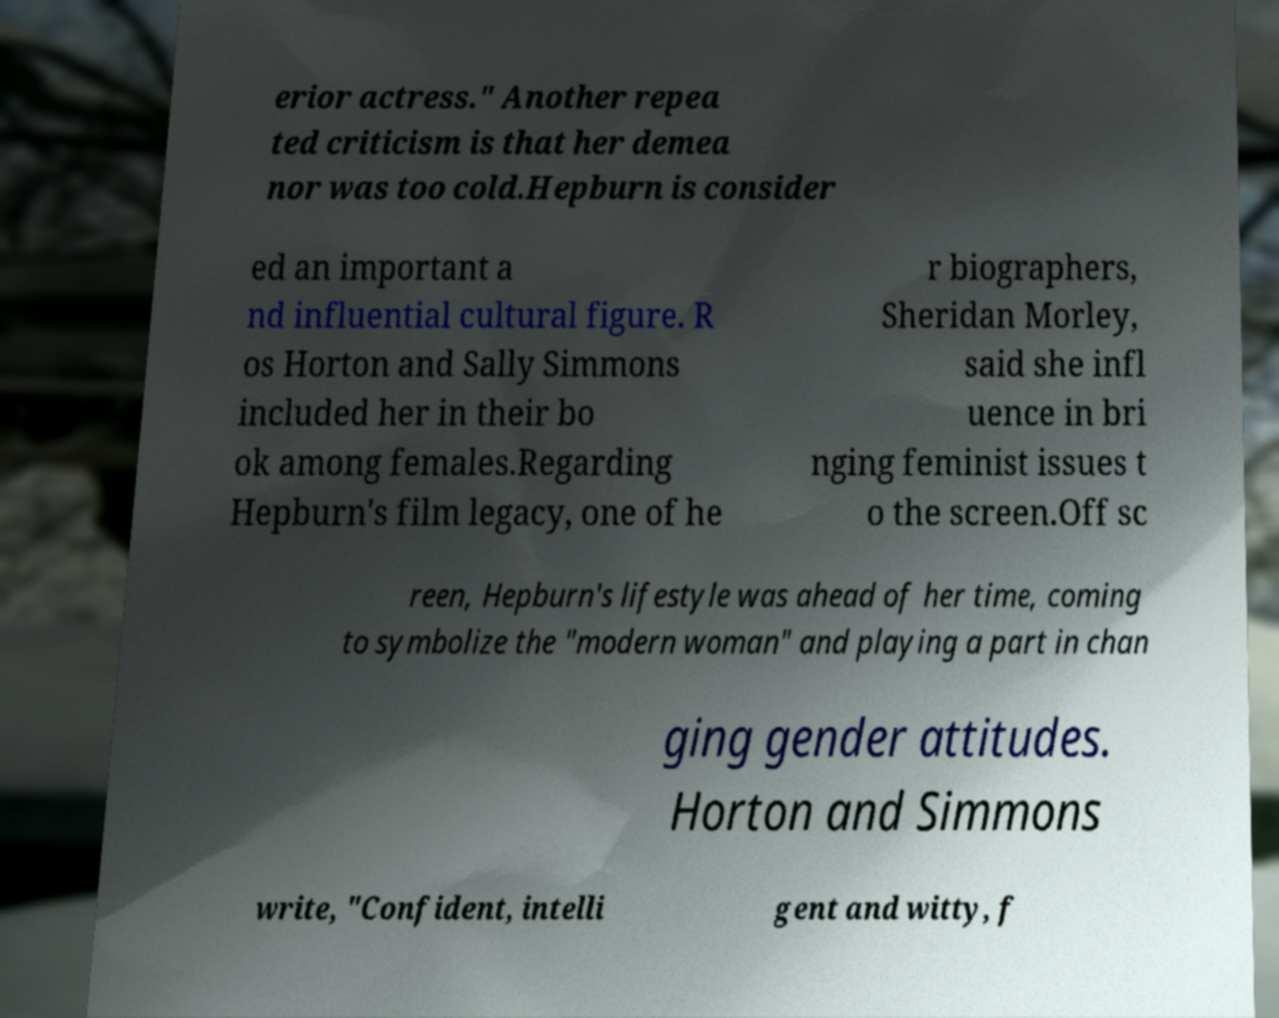Please identify and transcribe the text found in this image. erior actress." Another repea ted criticism is that her demea nor was too cold.Hepburn is consider ed an important a nd influential cultural figure. R os Horton and Sally Simmons included her in their bo ok among females.Regarding Hepburn's film legacy, one of he r biographers, Sheridan Morley, said she infl uence in bri nging feminist issues t o the screen.Off sc reen, Hepburn's lifestyle was ahead of her time, coming to symbolize the "modern woman" and playing a part in chan ging gender attitudes. Horton and Simmons write, "Confident, intelli gent and witty, f 